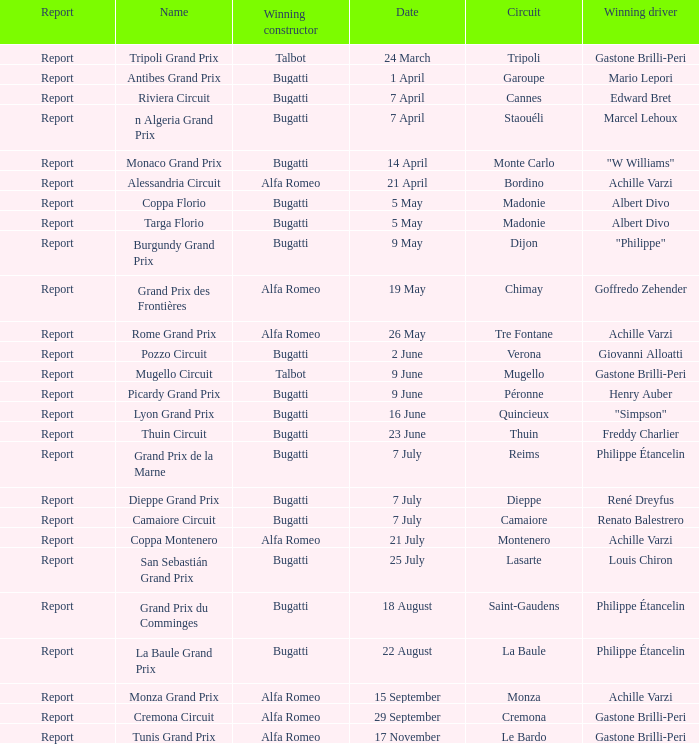What Circuit has a Winning constructor of bugatti, and a Winning driver of edward bret? Cannes. 